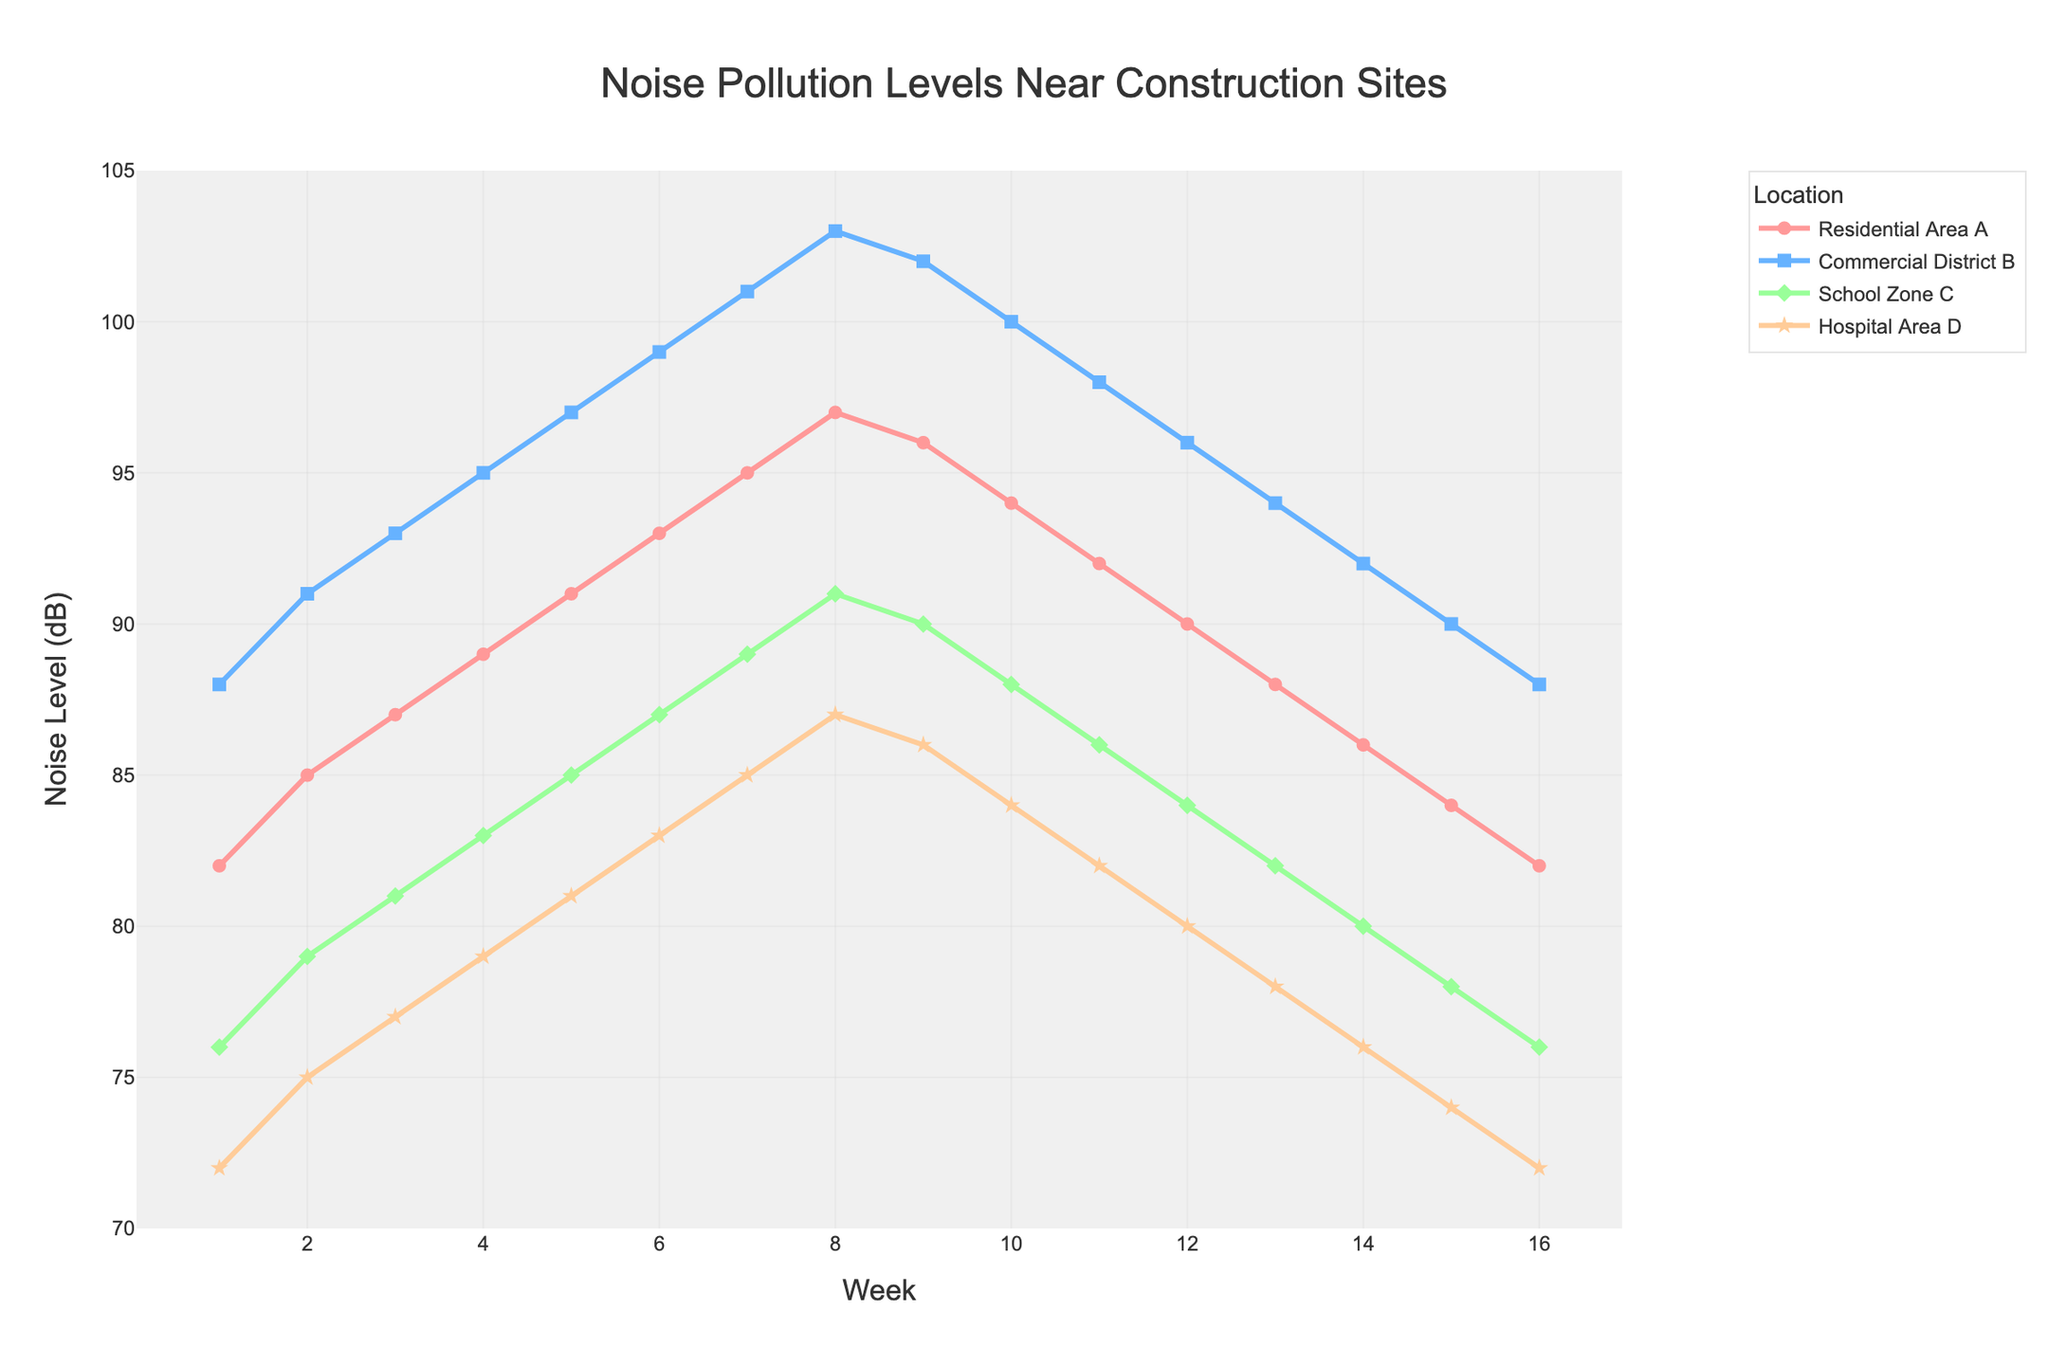What is the noise pollution level in the Commercial District B during Week 8? To find the noise pollution level in Commercial District B during Week 8, look at the data point at Week 8 for that area which is marked with squares on the chart.
Answer: 103 dB Which area experienced the highest noise pollution level and during which week? To determine the highest noise level, look for the peak value across all lines on the chart. The highest value is in Commercial District B, reaching 103 dB during Week 8.
Answer: Commercial District B, Week 8 By how many dB did the noise pollution level in Hospital Area D increase from Week 1 to Week 5? Identify the noise level for Hospital Area D in Weeks 1 and 5 from the figure. In Week 1, it was 72 dB, and in Week 5, it was 81 dB. Subtract the Week 1 value from the Week 5 value (81 - 72).
Answer: 9 dB Which area had the least variation in noise pollution levels over the 16 weeks? Assess the range of values (difference between minimum and maximum) for each area. The visual inspection shows Hospital Area D has the least change ranging from 72 dB to 87 dB.
Answer: Hospital Area D Compare the noise levels in School Zone C and Residential Area A during Week 9. Locate Week 9 on the chart and compare the data points for School Zone C (marked with diamonds) and Residential Area A (marked with circles). School Zone C is at 90 dB and Residential Area A at 96 dB.
Answer: School Zone C: 90 dB, Residential Area A: 96 dB What trend can be observed in Residential Area A's noise pollution levels over the first 8 weeks? Look at the line representing Residential Area A from Week 1 to Week 8. It shows a steady increase from 82 dB to 97 dB.
Answer: Steady increase What is the average noise pollution level in School Zone C during the first 4 weeks? Calculate the average of the values for School Zone C in Weeks 1-4: (76 + 79 + 81 + 83) / 4.
Answer: 79.75 dB How does the noise pollution trend in Hospital Area D compare to Commercial District B in the last 4 weeks? Examine the chart from Week 13 to Week 16 for both areas. Hospital Area D shows a consistent decrease, while Commercial District B has a steady decrease but at higher values.
Answer: Both decrease, but Hospital Area D remains lower Which week marks the peak noise pollution level in the Residential Area A? Identify the peak value in the line representing Residential Area A. The highest point is at Week 8 with 97 dB before it starts to decline.
Answer: Week 8 What is the difference in noise pollution levels between School Zone C and Commercial District B in Week 2? Find the values for Week 2 for School Zone C (79 dB) and Commercial District B (91 dB). Subtract the value for School Zone C from that for Commercial District B (91 - 79).
Answer: 12 dB 